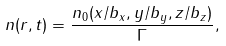Convert formula to latex. <formula><loc_0><loc_0><loc_500><loc_500>n ( { r } , t ) = \frac { n _ { 0 } ( x / b _ { x } , y / b _ { y } , z / b _ { z } ) } { \Gamma } ,</formula> 